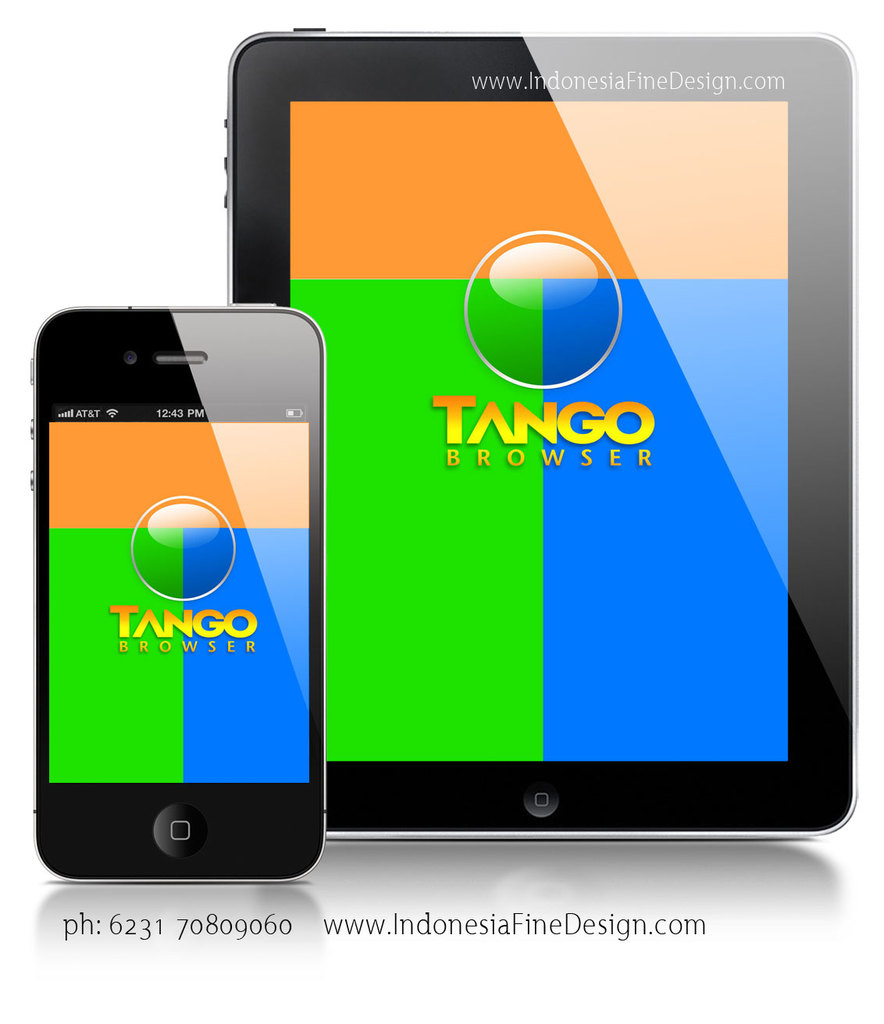How does the Tango Browser app improve user experience on different devices shown in the image? The Tango Browser app seems to be optimized for both smartphones and tablets, as indicated by the responsive design shown in the image. It adapts seamlessly to different screen sizes and resolutions, offering a consistent and accessible user interface across devices which enhances the browsing experience by maintaining design uniformity and usability. 